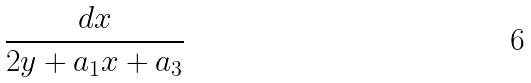Convert formula to latex. <formula><loc_0><loc_0><loc_500><loc_500>\frac { d x } { 2 y + a _ { 1 } x + a _ { 3 } }</formula> 